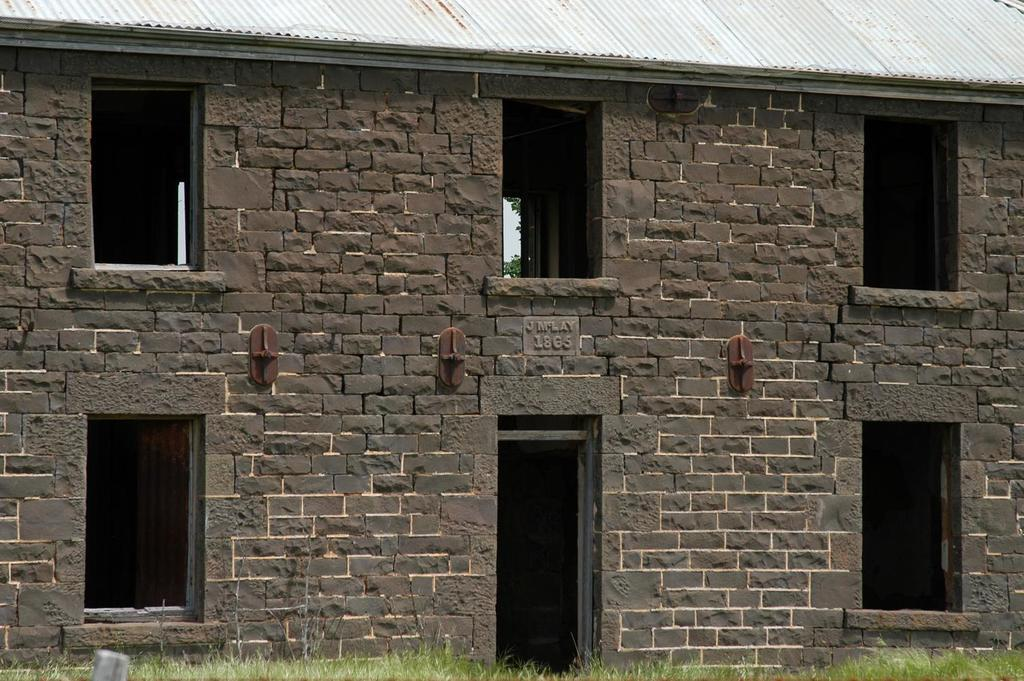Where was the image taken? The image is taken outdoors. What type of surface is visible in the image? There is a ground with grass in the image. What structure can be seen in the image? There is a building in the image. Can you describe the building's features? The building has walls, windows, a door, and a roof. How long does the battle between the crayons last in the image? There is no battle or crayons present in the image. How many minutes does it take for the minute hand to move in the image? There is no clock or time-related element present in the image. 